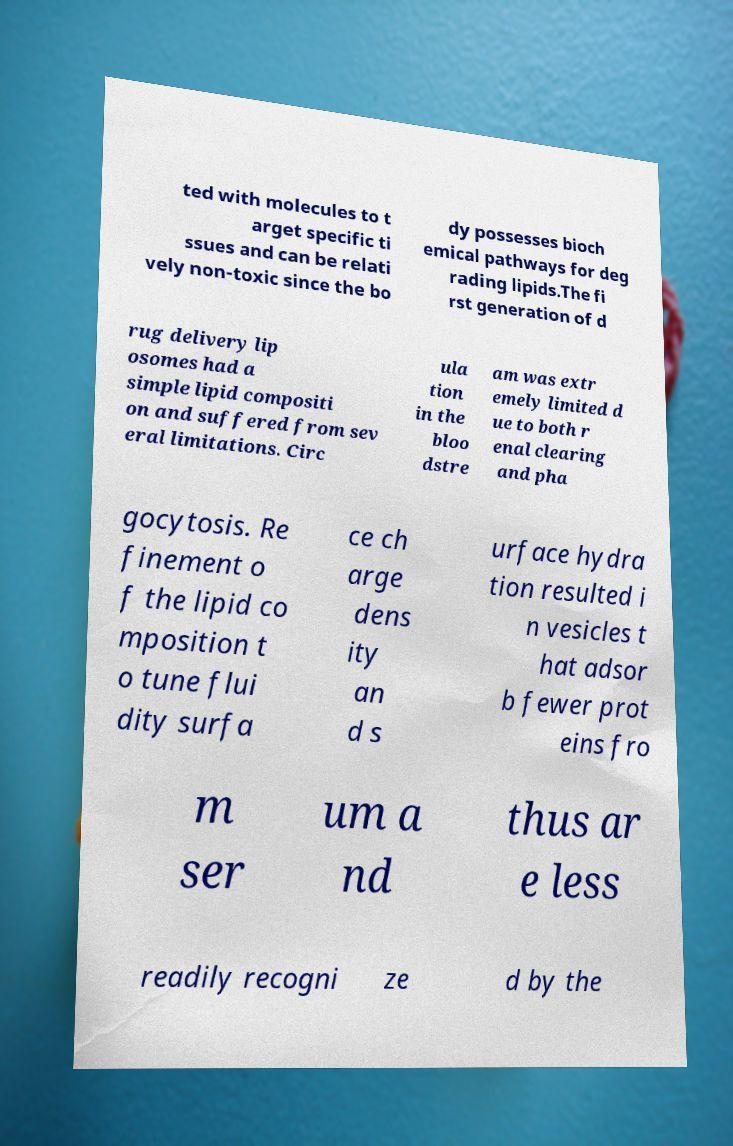There's text embedded in this image that I need extracted. Can you transcribe it verbatim? ted with molecules to t arget specific ti ssues and can be relati vely non-toxic since the bo dy possesses bioch emical pathways for deg rading lipids.The fi rst generation of d rug delivery lip osomes had a simple lipid compositi on and suffered from sev eral limitations. Circ ula tion in the bloo dstre am was extr emely limited d ue to both r enal clearing and pha gocytosis. Re finement o f the lipid co mposition t o tune flui dity surfa ce ch arge dens ity an d s urface hydra tion resulted i n vesicles t hat adsor b fewer prot eins fro m ser um a nd thus ar e less readily recogni ze d by the 